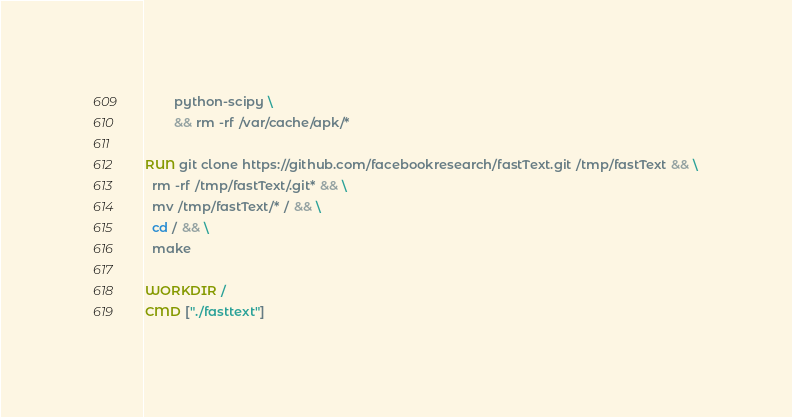Convert code to text. <code><loc_0><loc_0><loc_500><loc_500><_Dockerfile_>        python-scipy \
        && rm -rf /var/cache/apk/*

RUN git clone https://github.com/facebookresearch/fastText.git /tmp/fastText && \
  rm -rf /tmp/fastText/.git* && \
  mv /tmp/fastText/* / && \
  cd / && \
  make

WORKDIR /
CMD ["./fasttext"]
</code> 